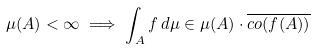Convert formula to latex. <formula><loc_0><loc_0><loc_500><loc_500>\mu ( A ) < \infty \implies \int _ { A } f \, d \mu \in \mu ( A ) \cdot { \overline { c o ( f ( A ) ) } }</formula> 